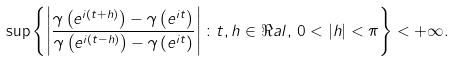Convert formula to latex. <formula><loc_0><loc_0><loc_500><loc_500>\sup \left \{ \left | \frac { \gamma \left ( e ^ { i ( t + h ) } \right ) - \gamma \left ( e ^ { i t } \right ) } { \gamma \left ( e ^ { i ( t - h ) } \right ) - \gamma \left ( e ^ { i t } \right ) } \right | \colon t , h \in \Re a l , \, 0 < | h | < \pi \right \} < + \infty .</formula> 